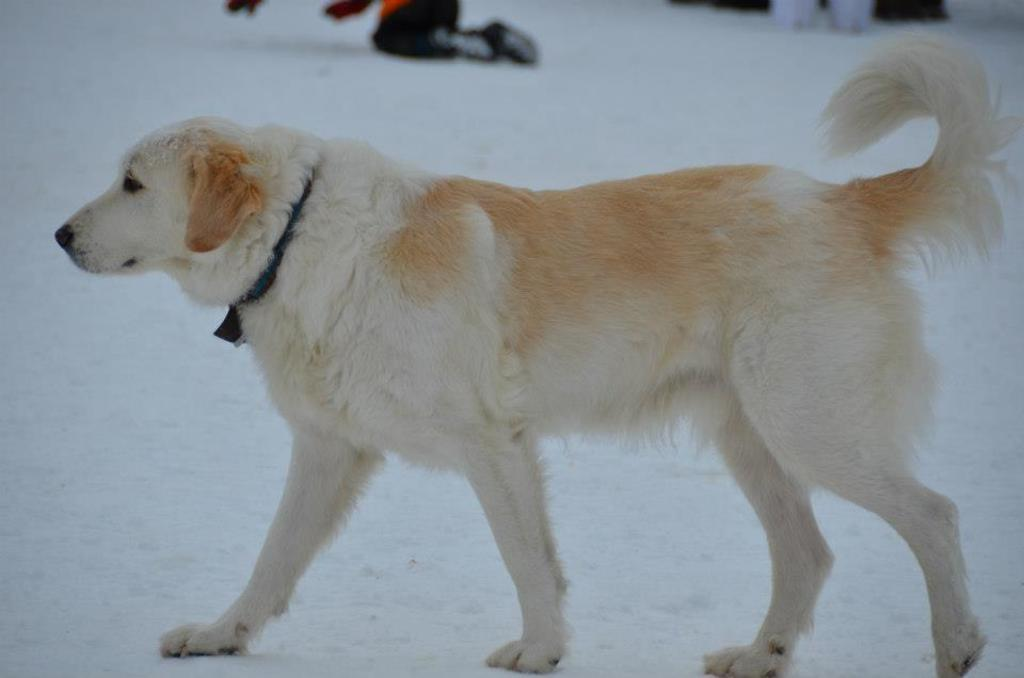What animal is present in the image? There is a dog in the image. Where is the dog located? The dog is on the ground. Can you see any people in the image? Yes, there are legs of persons visible in the image. What type of cracker is the dog eating in the image? There is no cracker present in the image, and the dog is not shown eating anything. 